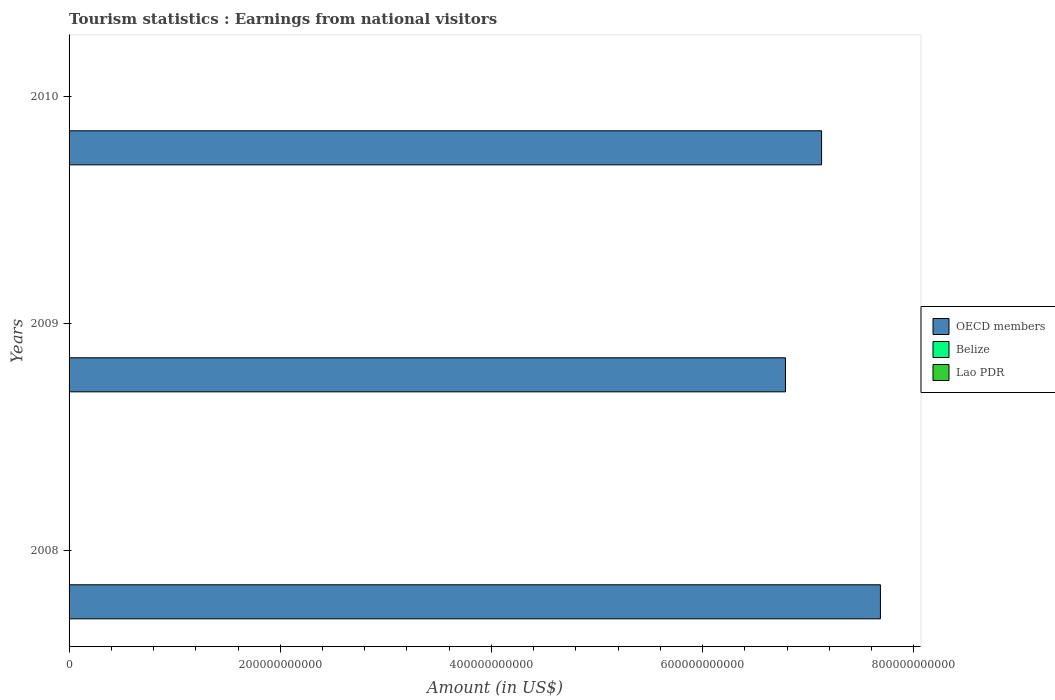How many different coloured bars are there?
Make the answer very short. 3. What is the label of the 2nd group of bars from the top?
Provide a short and direct response. 2009. What is the earnings from national visitors in OECD members in 2010?
Ensure brevity in your answer.  7.13e+11. Across all years, what is the maximum earnings from national visitors in Belize?
Give a very brief answer. 2.78e+08. Across all years, what is the minimum earnings from national visitors in Lao PDR?
Offer a very short reply. 2.71e+08. In which year was the earnings from national visitors in OECD members maximum?
Your answer should be very brief. 2008. In which year was the earnings from national visitors in OECD members minimum?
Ensure brevity in your answer.  2009. What is the total earnings from national visitors in Belize in the graph?
Keep it short and to the point. 7.98e+08. What is the difference between the earnings from national visitors in Belize in 2008 and that in 2010?
Provide a succinct answer. 1.40e+07. What is the difference between the earnings from national visitors in Lao PDR in 2010 and the earnings from national visitors in Belize in 2009?
Give a very brief answer. 1.29e+08. What is the average earnings from national visitors in OECD members per year?
Your answer should be very brief. 7.20e+11. In the year 2010, what is the difference between the earnings from national visitors in OECD members and earnings from national visitors in Belize?
Your response must be concise. 7.12e+11. In how many years, is the earnings from national visitors in Belize greater than 520000000000 US$?
Your response must be concise. 0. What is the ratio of the earnings from national visitors in OECD members in 2008 to that in 2009?
Your answer should be compact. 1.13. What is the difference between the highest and the second highest earnings from national visitors in OECD members?
Your answer should be very brief. 5.57e+1. What is the difference between the highest and the lowest earnings from national visitors in Belize?
Your response must be concise. 2.20e+07. What does the 1st bar from the top in 2009 represents?
Ensure brevity in your answer.  Lao PDR. What does the 3rd bar from the bottom in 2010 represents?
Your response must be concise. Lao PDR. Are all the bars in the graph horizontal?
Offer a terse response. Yes. How many years are there in the graph?
Offer a very short reply. 3. What is the difference between two consecutive major ticks on the X-axis?
Keep it short and to the point. 2.00e+11. Does the graph contain any zero values?
Your answer should be compact. No. Does the graph contain grids?
Provide a short and direct response. No. What is the title of the graph?
Your answer should be very brief. Tourism statistics : Earnings from national visitors. What is the Amount (in US$) in OECD members in 2008?
Keep it short and to the point. 7.68e+11. What is the Amount (in US$) in Belize in 2008?
Make the answer very short. 2.78e+08. What is the Amount (in US$) of Lao PDR in 2008?
Your answer should be very brief. 2.80e+08. What is the Amount (in US$) of OECD members in 2009?
Make the answer very short. 6.79e+11. What is the Amount (in US$) of Belize in 2009?
Offer a very short reply. 2.56e+08. What is the Amount (in US$) of Lao PDR in 2009?
Provide a succinct answer. 2.71e+08. What is the Amount (in US$) in OECD members in 2010?
Your response must be concise. 7.13e+11. What is the Amount (in US$) of Belize in 2010?
Offer a terse response. 2.64e+08. What is the Amount (in US$) in Lao PDR in 2010?
Provide a succinct answer. 3.85e+08. Across all years, what is the maximum Amount (in US$) of OECD members?
Your response must be concise. 7.68e+11. Across all years, what is the maximum Amount (in US$) in Belize?
Make the answer very short. 2.78e+08. Across all years, what is the maximum Amount (in US$) of Lao PDR?
Make the answer very short. 3.85e+08. Across all years, what is the minimum Amount (in US$) in OECD members?
Provide a short and direct response. 6.79e+11. Across all years, what is the minimum Amount (in US$) in Belize?
Your answer should be compact. 2.56e+08. Across all years, what is the minimum Amount (in US$) of Lao PDR?
Offer a very short reply. 2.71e+08. What is the total Amount (in US$) of OECD members in the graph?
Provide a succinct answer. 2.16e+12. What is the total Amount (in US$) in Belize in the graph?
Ensure brevity in your answer.  7.98e+08. What is the total Amount (in US$) of Lao PDR in the graph?
Your answer should be compact. 9.36e+08. What is the difference between the Amount (in US$) of OECD members in 2008 and that in 2009?
Make the answer very short. 8.99e+1. What is the difference between the Amount (in US$) in Belize in 2008 and that in 2009?
Give a very brief answer. 2.20e+07. What is the difference between the Amount (in US$) in Lao PDR in 2008 and that in 2009?
Your answer should be very brief. 9.00e+06. What is the difference between the Amount (in US$) in OECD members in 2008 and that in 2010?
Provide a succinct answer. 5.57e+1. What is the difference between the Amount (in US$) of Belize in 2008 and that in 2010?
Your answer should be very brief. 1.40e+07. What is the difference between the Amount (in US$) in Lao PDR in 2008 and that in 2010?
Your answer should be compact. -1.05e+08. What is the difference between the Amount (in US$) of OECD members in 2009 and that in 2010?
Provide a short and direct response. -3.42e+1. What is the difference between the Amount (in US$) in Belize in 2009 and that in 2010?
Keep it short and to the point. -8.00e+06. What is the difference between the Amount (in US$) of Lao PDR in 2009 and that in 2010?
Your answer should be compact. -1.14e+08. What is the difference between the Amount (in US$) of OECD members in 2008 and the Amount (in US$) of Belize in 2009?
Your answer should be compact. 7.68e+11. What is the difference between the Amount (in US$) in OECD members in 2008 and the Amount (in US$) in Lao PDR in 2009?
Give a very brief answer. 7.68e+11. What is the difference between the Amount (in US$) in Belize in 2008 and the Amount (in US$) in Lao PDR in 2009?
Provide a short and direct response. 7.00e+06. What is the difference between the Amount (in US$) in OECD members in 2008 and the Amount (in US$) in Belize in 2010?
Provide a succinct answer. 7.68e+11. What is the difference between the Amount (in US$) in OECD members in 2008 and the Amount (in US$) in Lao PDR in 2010?
Your answer should be compact. 7.68e+11. What is the difference between the Amount (in US$) of Belize in 2008 and the Amount (in US$) of Lao PDR in 2010?
Ensure brevity in your answer.  -1.07e+08. What is the difference between the Amount (in US$) in OECD members in 2009 and the Amount (in US$) in Belize in 2010?
Your answer should be very brief. 6.78e+11. What is the difference between the Amount (in US$) in OECD members in 2009 and the Amount (in US$) in Lao PDR in 2010?
Provide a succinct answer. 6.78e+11. What is the difference between the Amount (in US$) in Belize in 2009 and the Amount (in US$) in Lao PDR in 2010?
Offer a very short reply. -1.29e+08. What is the average Amount (in US$) in OECD members per year?
Your response must be concise. 7.20e+11. What is the average Amount (in US$) of Belize per year?
Offer a very short reply. 2.66e+08. What is the average Amount (in US$) in Lao PDR per year?
Provide a succinct answer. 3.12e+08. In the year 2008, what is the difference between the Amount (in US$) of OECD members and Amount (in US$) of Belize?
Give a very brief answer. 7.68e+11. In the year 2008, what is the difference between the Amount (in US$) in OECD members and Amount (in US$) in Lao PDR?
Give a very brief answer. 7.68e+11. In the year 2009, what is the difference between the Amount (in US$) in OECD members and Amount (in US$) in Belize?
Offer a terse response. 6.78e+11. In the year 2009, what is the difference between the Amount (in US$) in OECD members and Amount (in US$) in Lao PDR?
Offer a terse response. 6.78e+11. In the year 2009, what is the difference between the Amount (in US$) in Belize and Amount (in US$) in Lao PDR?
Your answer should be very brief. -1.50e+07. In the year 2010, what is the difference between the Amount (in US$) in OECD members and Amount (in US$) in Belize?
Your answer should be compact. 7.12e+11. In the year 2010, what is the difference between the Amount (in US$) in OECD members and Amount (in US$) in Lao PDR?
Provide a succinct answer. 7.12e+11. In the year 2010, what is the difference between the Amount (in US$) in Belize and Amount (in US$) in Lao PDR?
Make the answer very short. -1.21e+08. What is the ratio of the Amount (in US$) of OECD members in 2008 to that in 2009?
Provide a succinct answer. 1.13. What is the ratio of the Amount (in US$) of Belize in 2008 to that in 2009?
Make the answer very short. 1.09. What is the ratio of the Amount (in US$) in Lao PDR in 2008 to that in 2009?
Provide a short and direct response. 1.03. What is the ratio of the Amount (in US$) in OECD members in 2008 to that in 2010?
Your answer should be very brief. 1.08. What is the ratio of the Amount (in US$) in Belize in 2008 to that in 2010?
Provide a succinct answer. 1.05. What is the ratio of the Amount (in US$) in Lao PDR in 2008 to that in 2010?
Give a very brief answer. 0.73. What is the ratio of the Amount (in US$) of OECD members in 2009 to that in 2010?
Keep it short and to the point. 0.95. What is the ratio of the Amount (in US$) in Belize in 2009 to that in 2010?
Offer a terse response. 0.97. What is the ratio of the Amount (in US$) of Lao PDR in 2009 to that in 2010?
Offer a terse response. 0.7. What is the difference between the highest and the second highest Amount (in US$) of OECD members?
Offer a very short reply. 5.57e+1. What is the difference between the highest and the second highest Amount (in US$) in Belize?
Make the answer very short. 1.40e+07. What is the difference between the highest and the second highest Amount (in US$) in Lao PDR?
Provide a short and direct response. 1.05e+08. What is the difference between the highest and the lowest Amount (in US$) in OECD members?
Give a very brief answer. 8.99e+1. What is the difference between the highest and the lowest Amount (in US$) in Belize?
Give a very brief answer. 2.20e+07. What is the difference between the highest and the lowest Amount (in US$) of Lao PDR?
Your answer should be very brief. 1.14e+08. 